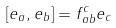<formula> <loc_0><loc_0><loc_500><loc_500>[ e _ { a } , e _ { b } ] = f _ { a b } ^ { c } e _ { c }</formula> 